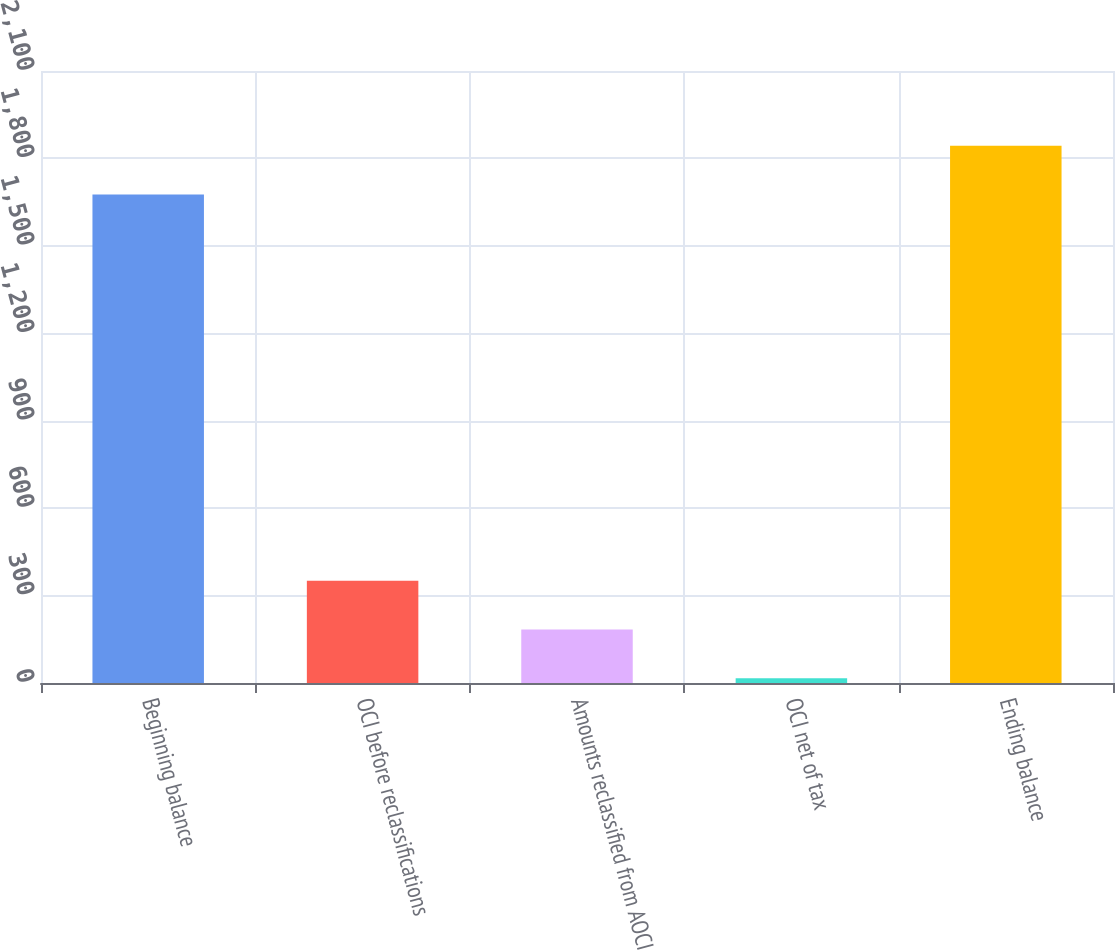Convert chart. <chart><loc_0><loc_0><loc_500><loc_500><bar_chart><fcel>Beginning balance<fcel>OCI before reclassifications<fcel>Amounts reclassified from AOCI<fcel>OCI net of tax<fcel>Ending balance<nl><fcel>1676<fcel>351.2<fcel>183.6<fcel>16<fcel>1843.6<nl></chart> 